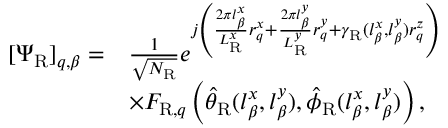Convert formula to latex. <formula><loc_0><loc_0><loc_500><loc_500>\begin{array} { r l } { [ \Psi _ { R } ] _ { q , \beta } = } & { \frac { 1 } { \sqrt { N _ { R } } } e ^ { j \left ( \frac { 2 \pi l _ { \beta } ^ { x } } { L _ { R } ^ { x } } r _ { q } ^ { x } + \frac { 2 \pi l _ { \beta } ^ { y } } { L _ { R } ^ { y } } r _ { q } ^ { y } + \gamma _ { R } ( l _ { \beta } ^ { x } , l _ { \beta } ^ { y } ) r _ { q } ^ { z } \right ) } } \\ & { \times F _ { R , q } \left ( \hat { \theta } _ { R } ( l _ { \beta } ^ { x } , l _ { \beta } ^ { y } ) , \hat { \phi } _ { R } ( l _ { \beta } ^ { x } , l _ { \beta } ^ { y } ) \right ) , } \end{array}</formula> 